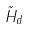<formula> <loc_0><loc_0><loc_500><loc_500>\tilde { H } _ { d }</formula> 